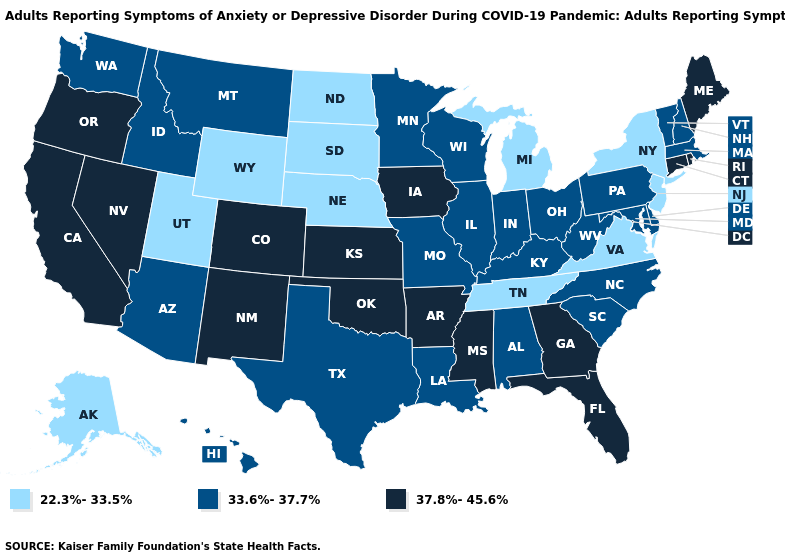Name the states that have a value in the range 33.6%-37.7%?
Keep it brief. Alabama, Arizona, Delaware, Hawaii, Idaho, Illinois, Indiana, Kentucky, Louisiana, Maryland, Massachusetts, Minnesota, Missouri, Montana, New Hampshire, North Carolina, Ohio, Pennsylvania, South Carolina, Texas, Vermont, Washington, West Virginia, Wisconsin. Name the states that have a value in the range 22.3%-33.5%?
Be succinct. Alaska, Michigan, Nebraska, New Jersey, New York, North Dakota, South Dakota, Tennessee, Utah, Virginia, Wyoming. Name the states that have a value in the range 33.6%-37.7%?
Keep it brief. Alabama, Arizona, Delaware, Hawaii, Idaho, Illinois, Indiana, Kentucky, Louisiana, Maryland, Massachusetts, Minnesota, Missouri, Montana, New Hampshire, North Carolina, Ohio, Pennsylvania, South Carolina, Texas, Vermont, Washington, West Virginia, Wisconsin. What is the value of Missouri?
Answer briefly. 33.6%-37.7%. Name the states that have a value in the range 33.6%-37.7%?
Concise answer only. Alabama, Arizona, Delaware, Hawaii, Idaho, Illinois, Indiana, Kentucky, Louisiana, Maryland, Massachusetts, Minnesota, Missouri, Montana, New Hampshire, North Carolina, Ohio, Pennsylvania, South Carolina, Texas, Vermont, Washington, West Virginia, Wisconsin. Among the states that border California , which have the lowest value?
Answer briefly. Arizona. Which states have the lowest value in the USA?
Be succinct. Alaska, Michigan, Nebraska, New Jersey, New York, North Dakota, South Dakota, Tennessee, Utah, Virginia, Wyoming. Does Oregon have the lowest value in the West?
Write a very short answer. No. Name the states that have a value in the range 37.8%-45.6%?
Answer briefly. Arkansas, California, Colorado, Connecticut, Florida, Georgia, Iowa, Kansas, Maine, Mississippi, Nevada, New Mexico, Oklahoma, Oregon, Rhode Island. Does New York have the lowest value in the Northeast?
Quick response, please. Yes. Does New Jersey have the lowest value in the Northeast?
Write a very short answer. Yes. What is the lowest value in the Northeast?
Concise answer only. 22.3%-33.5%. Among the states that border Oklahoma , which have the highest value?
Answer briefly. Arkansas, Colorado, Kansas, New Mexico. Name the states that have a value in the range 37.8%-45.6%?
Write a very short answer. Arkansas, California, Colorado, Connecticut, Florida, Georgia, Iowa, Kansas, Maine, Mississippi, Nevada, New Mexico, Oklahoma, Oregon, Rhode Island. Does Washington have the highest value in the West?
Give a very brief answer. No. 